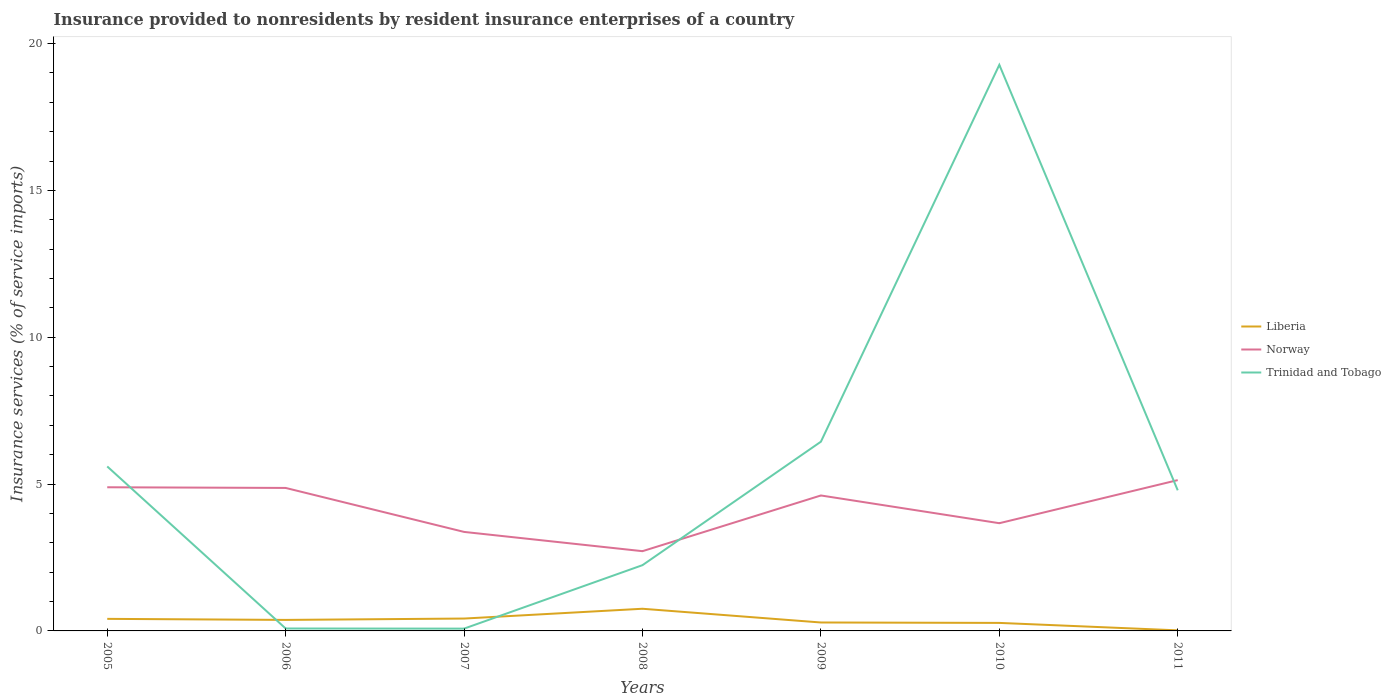How many different coloured lines are there?
Give a very brief answer. 3. Is the number of lines equal to the number of legend labels?
Give a very brief answer. Yes. Across all years, what is the maximum insurance provided to nonresidents in Trinidad and Tobago?
Provide a succinct answer. 0.08. In which year was the insurance provided to nonresidents in Liberia maximum?
Offer a very short reply. 2011. What is the total insurance provided to nonresidents in Trinidad and Tobago in the graph?
Offer a terse response. -19.2. What is the difference between the highest and the second highest insurance provided to nonresidents in Norway?
Offer a very short reply. 2.42. What is the difference between the highest and the lowest insurance provided to nonresidents in Trinidad and Tobago?
Your response must be concise. 3. Is the insurance provided to nonresidents in Norway strictly greater than the insurance provided to nonresidents in Liberia over the years?
Keep it short and to the point. No. Are the values on the major ticks of Y-axis written in scientific E-notation?
Make the answer very short. No. Does the graph contain any zero values?
Your answer should be compact. No. Where does the legend appear in the graph?
Ensure brevity in your answer.  Center right. What is the title of the graph?
Offer a terse response. Insurance provided to nonresidents by resident insurance enterprises of a country. What is the label or title of the Y-axis?
Provide a succinct answer. Insurance services (% of service imports). What is the Insurance services (% of service imports) in Liberia in 2005?
Offer a terse response. 0.41. What is the Insurance services (% of service imports) of Norway in 2005?
Ensure brevity in your answer.  4.89. What is the Insurance services (% of service imports) in Trinidad and Tobago in 2005?
Offer a terse response. 5.6. What is the Insurance services (% of service imports) of Liberia in 2006?
Provide a succinct answer. 0.38. What is the Insurance services (% of service imports) in Norway in 2006?
Ensure brevity in your answer.  4.87. What is the Insurance services (% of service imports) of Trinidad and Tobago in 2006?
Make the answer very short. 0.08. What is the Insurance services (% of service imports) of Liberia in 2007?
Provide a short and direct response. 0.42. What is the Insurance services (% of service imports) of Norway in 2007?
Offer a terse response. 3.37. What is the Insurance services (% of service imports) in Trinidad and Tobago in 2007?
Offer a very short reply. 0.08. What is the Insurance services (% of service imports) of Liberia in 2008?
Ensure brevity in your answer.  0.75. What is the Insurance services (% of service imports) of Norway in 2008?
Make the answer very short. 2.72. What is the Insurance services (% of service imports) of Trinidad and Tobago in 2008?
Your answer should be very brief. 2.24. What is the Insurance services (% of service imports) in Liberia in 2009?
Keep it short and to the point. 0.29. What is the Insurance services (% of service imports) of Norway in 2009?
Offer a very short reply. 4.61. What is the Insurance services (% of service imports) in Trinidad and Tobago in 2009?
Make the answer very short. 6.44. What is the Insurance services (% of service imports) in Liberia in 2010?
Keep it short and to the point. 0.27. What is the Insurance services (% of service imports) of Norway in 2010?
Your answer should be compact. 3.67. What is the Insurance services (% of service imports) of Trinidad and Tobago in 2010?
Give a very brief answer. 19.28. What is the Insurance services (% of service imports) of Liberia in 2011?
Offer a terse response. 0.02. What is the Insurance services (% of service imports) of Norway in 2011?
Offer a terse response. 5.14. What is the Insurance services (% of service imports) of Trinidad and Tobago in 2011?
Make the answer very short. 4.79. Across all years, what is the maximum Insurance services (% of service imports) in Liberia?
Offer a very short reply. 0.75. Across all years, what is the maximum Insurance services (% of service imports) of Norway?
Give a very brief answer. 5.14. Across all years, what is the maximum Insurance services (% of service imports) of Trinidad and Tobago?
Your answer should be very brief. 19.28. Across all years, what is the minimum Insurance services (% of service imports) of Liberia?
Ensure brevity in your answer.  0.02. Across all years, what is the minimum Insurance services (% of service imports) in Norway?
Your answer should be compact. 2.72. Across all years, what is the minimum Insurance services (% of service imports) in Trinidad and Tobago?
Make the answer very short. 0.08. What is the total Insurance services (% of service imports) in Liberia in the graph?
Offer a very short reply. 2.54. What is the total Insurance services (% of service imports) of Norway in the graph?
Your response must be concise. 29.26. What is the total Insurance services (% of service imports) of Trinidad and Tobago in the graph?
Provide a succinct answer. 38.51. What is the difference between the Insurance services (% of service imports) in Liberia in 2005 and that in 2006?
Give a very brief answer. 0.04. What is the difference between the Insurance services (% of service imports) in Norway in 2005 and that in 2006?
Provide a succinct answer. 0.02. What is the difference between the Insurance services (% of service imports) in Trinidad and Tobago in 2005 and that in 2006?
Provide a succinct answer. 5.52. What is the difference between the Insurance services (% of service imports) of Liberia in 2005 and that in 2007?
Offer a very short reply. -0.01. What is the difference between the Insurance services (% of service imports) of Norway in 2005 and that in 2007?
Ensure brevity in your answer.  1.52. What is the difference between the Insurance services (% of service imports) in Trinidad and Tobago in 2005 and that in 2007?
Your response must be concise. 5.52. What is the difference between the Insurance services (% of service imports) of Liberia in 2005 and that in 2008?
Your response must be concise. -0.34. What is the difference between the Insurance services (% of service imports) of Norway in 2005 and that in 2008?
Offer a very short reply. 2.18. What is the difference between the Insurance services (% of service imports) of Trinidad and Tobago in 2005 and that in 2008?
Ensure brevity in your answer.  3.36. What is the difference between the Insurance services (% of service imports) in Liberia in 2005 and that in 2009?
Offer a terse response. 0.12. What is the difference between the Insurance services (% of service imports) of Norway in 2005 and that in 2009?
Provide a short and direct response. 0.28. What is the difference between the Insurance services (% of service imports) of Trinidad and Tobago in 2005 and that in 2009?
Your answer should be very brief. -0.84. What is the difference between the Insurance services (% of service imports) of Liberia in 2005 and that in 2010?
Ensure brevity in your answer.  0.14. What is the difference between the Insurance services (% of service imports) in Norway in 2005 and that in 2010?
Offer a terse response. 1.22. What is the difference between the Insurance services (% of service imports) of Trinidad and Tobago in 2005 and that in 2010?
Provide a short and direct response. -13.67. What is the difference between the Insurance services (% of service imports) of Liberia in 2005 and that in 2011?
Your response must be concise. 0.39. What is the difference between the Insurance services (% of service imports) of Norway in 2005 and that in 2011?
Your response must be concise. -0.24. What is the difference between the Insurance services (% of service imports) in Trinidad and Tobago in 2005 and that in 2011?
Provide a succinct answer. 0.81. What is the difference between the Insurance services (% of service imports) in Liberia in 2006 and that in 2007?
Your answer should be very brief. -0.05. What is the difference between the Insurance services (% of service imports) of Norway in 2006 and that in 2007?
Your response must be concise. 1.5. What is the difference between the Insurance services (% of service imports) of Trinidad and Tobago in 2006 and that in 2007?
Provide a short and direct response. 0. What is the difference between the Insurance services (% of service imports) in Liberia in 2006 and that in 2008?
Offer a terse response. -0.38. What is the difference between the Insurance services (% of service imports) of Norway in 2006 and that in 2008?
Provide a short and direct response. 2.15. What is the difference between the Insurance services (% of service imports) in Trinidad and Tobago in 2006 and that in 2008?
Ensure brevity in your answer.  -2.16. What is the difference between the Insurance services (% of service imports) in Liberia in 2006 and that in 2009?
Keep it short and to the point. 0.09. What is the difference between the Insurance services (% of service imports) of Norway in 2006 and that in 2009?
Your answer should be compact. 0.26. What is the difference between the Insurance services (% of service imports) of Trinidad and Tobago in 2006 and that in 2009?
Provide a short and direct response. -6.36. What is the difference between the Insurance services (% of service imports) in Liberia in 2006 and that in 2010?
Ensure brevity in your answer.  0.1. What is the difference between the Insurance services (% of service imports) of Norway in 2006 and that in 2010?
Provide a succinct answer. 1.2. What is the difference between the Insurance services (% of service imports) in Trinidad and Tobago in 2006 and that in 2010?
Provide a succinct answer. -19.19. What is the difference between the Insurance services (% of service imports) in Liberia in 2006 and that in 2011?
Your response must be concise. 0.36. What is the difference between the Insurance services (% of service imports) in Norway in 2006 and that in 2011?
Ensure brevity in your answer.  -0.27. What is the difference between the Insurance services (% of service imports) in Trinidad and Tobago in 2006 and that in 2011?
Make the answer very short. -4.71. What is the difference between the Insurance services (% of service imports) of Liberia in 2007 and that in 2008?
Give a very brief answer. -0.33. What is the difference between the Insurance services (% of service imports) in Norway in 2007 and that in 2008?
Provide a short and direct response. 0.66. What is the difference between the Insurance services (% of service imports) in Trinidad and Tobago in 2007 and that in 2008?
Offer a very short reply. -2.16. What is the difference between the Insurance services (% of service imports) in Liberia in 2007 and that in 2009?
Offer a terse response. 0.13. What is the difference between the Insurance services (% of service imports) of Norway in 2007 and that in 2009?
Offer a very short reply. -1.24. What is the difference between the Insurance services (% of service imports) of Trinidad and Tobago in 2007 and that in 2009?
Provide a succinct answer. -6.37. What is the difference between the Insurance services (% of service imports) of Liberia in 2007 and that in 2010?
Your answer should be compact. 0.15. What is the difference between the Insurance services (% of service imports) in Norway in 2007 and that in 2010?
Offer a very short reply. -0.3. What is the difference between the Insurance services (% of service imports) in Trinidad and Tobago in 2007 and that in 2010?
Ensure brevity in your answer.  -19.2. What is the difference between the Insurance services (% of service imports) of Liberia in 2007 and that in 2011?
Your answer should be compact. 0.4. What is the difference between the Insurance services (% of service imports) of Norway in 2007 and that in 2011?
Give a very brief answer. -1.76. What is the difference between the Insurance services (% of service imports) in Trinidad and Tobago in 2007 and that in 2011?
Make the answer very short. -4.71. What is the difference between the Insurance services (% of service imports) of Liberia in 2008 and that in 2009?
Offer a very short reply. 0.47. What is the difference between the Insurance services (% of service imports) in Norway in 2008 and that in 2009?
Offer a very short reply. -1.9. What is the difference between the Insurance services (% of service imports) of Trinidad and Tobago in 2008 and that in 2009?
Offer a very short reply. -4.2. What is the difference between the Insurance services (% of service imports) in Liberia in 2008 and that in 2010?
Ensure brevity in your answer.  0.48. What is the difference between the Insurance services (% of service imports) of Norway in 2008 and that in 2010?
Your answer should be compact. -0.95. What is the difference between the Insurance services (% of service imports) in Trinidad and Tobago in 2008 and that in 2010?
Provide a succinct answer. -17.04. What is the difference between the Insurance services (% of service imports) of Liberia in 2008 and that in 2011?
Give a very brief answer. 0.74. What is the difference between the Insurance services (% of service imports) of Norway in 2008 and that in 2011?
Provide a succinct answer. -2.42. What is the difference between the Insurance services (% of service imports) in Trinidad and Tobago in 2008 and that in 2011?
Offer a very short reply. -2.55. What is the difference between the Insurance services (% of service imports) in Liberia in 2009 and that in 2010?
Offer a terse response. 0.01. What is the difference between the Insurance services (% of service imports) of Norway in 2009 and that in 2010?
Give a very brief answer. 0.94. What is the difference between the Insurance services (% of service imports) of Trinidad and Tobago in 2009 and that in 2010?
Your response must be concise. -12.83. What is the difference between the Insurance services (% of service imports) in Liberia in 2009 and that in 2011?
Keep it short and to the point. 0.27. What is the difference between the Insurance services (% of service imports) in Norway in 2009 and that in 2011?
Your response must be concise. -0.52. What is the difference between the Insurance services (% of service imports) in Trinidad and Tobago in 2009 and that in 2011?
Keep it short and to the point. 1.66. What is the difference between the Insurance services (% of service imports) of Liberia in 2010 and that in 2011?
Make the answer very short. 0.25. What is the difference between the Insurance services (% of service imports) of Norway in 2010 and that in 2011?
Make the answer very short. -1.47. What is the difference between the Insurance services (% of service imports) in Trinidad and Tobago in 2010 and that in 2011?
Offer a very short reply. 14.49. What is the difference between the Insurance services (% of service imports) in Liberia in 2005 and the Insurance services (% of service imports) in Norway in 2006?
Ensure brevity in your answer.  -4.46. What is the difference between the Insurance services (% of service imports) of Liberia in 2005 and the Insurance services (% of service imports) of Trinidad and Tobago in 2006?
Provide a succinct answer. 0.33. What is the difference between the Insurance services (% of service imports) of Norway in 2005 and the Insurance services (% of service imports) of Trinidad and Tobago in 2006?
Ensure brevity in your answer.  4.81. What is the difference between the Insurance services (% of service imports) in Liberia in 2005 and the Insurance services (% of service imports) in Norway in 2007?
Your answer should be compact. -2.96. What is the difference between the Insurance services (% of service imports) in Liberia in 2005 and the Insurance services (% of service imports) in Trinidad and Tobago in 2007?
Provide a succinct answer. 0.33. What is the difference between the Insurance services (% of service imports) of Norway in 2005 and the Insurance services (% of service imports) of Trinidad and Tobago in 2007?
Provide a succinct answer. 4.81. What is the difference between the Insurance services (% of service imports) in Liberia in 2005 and the Insurance services (% of service imports) in Norway in 2008?
Your response must be concise. -2.3. What is the difference between the Insurance services (% of service imports) of Liberia in 2005 and the Insurance services (% of service imports) of Trinidad and Tobago in 2008?
Offer a very short reply. -1.83. What is the difference between the Insurance services (% of service imports) in Norway in 2005 and the Insurance services (% of service imports) in Trinidad and Tobago in 2008?
Make the answer very short. 2.65. What is the difference between the Insurance services (% of service imports) in Liberia in 2005 and the Insurance services (% of service imports) in Norway in 2009?
Keep it short and to the point. -4.2. What is the difference between the Insurance services (% of service imports) in Liberia in 2005 and the Insurance services (% of service imports) in Trinidad and Tobago in 2009?
Your answer should be compact. -6.03. What is the difference between the Insurance services (% of service imports) in Norway in 2005 and the Insurance services (% of service imports) in Trinidad and Tobago in 2009?
Keep it short and to the point. -1.55. What is the difference between the Insurance services (% of service imports) of Liberia in 2005 and the Insurance services (% of service imports) of Norway in 2010?
Keep it short and to the point. -3.26. What is the difference between the Insurance services (% of service imports) in Liberia in 2005 and the Insurance services (% of service imports) in Trinidad and Tobago in 2010?
Your answer should be very brief. -18.86. What is the difference between the Insurance services (% of service imports) in Norway in 2005 and the Insurance services (% of service imports) in Trinidad and Tobago in 2010?
Give a very brief answer. -14.38. What is the difference between the Insurance services (% of service imports) of Liberia in 2005 and the Insurance services (% of service imports) of Norway in 2011?
Offer a terse response. -4.72. What is the difference between the Insurance services (% of service imports) in Liberia in 2005 and the Insurance services (% of service imports) in Trinidad and Tobago in 2011?
Your response must be concise. -4.38. What is the difference between the Insurance services (% of service imports) of Norway in 2005 and the Insurance services (% of service imports) of Trinidad and Tobago in 2011?
Your response must be concise. 0.1. What is the difference between the Insurance services (% of service imports) of Liberia in 2006 and the Insurance services (% of service imports) of Norway in 2007?
Provide a short and direct response. -3. What is the difference between the Insurance services (% of service imports) in Liberia in 2006 and the Insurance services (% of service imports) in Trinidad and Tobago in 2007?
Keep it short and to the point. 0.3. What is the difference between the Insurance services (% of service imports) of Norway in 2006 and the Insurance services (% of service imports) of Trinidad and Tobago in 2007?
Offer a very short reply. 4.79. What is the difference between the Insurance services (% of service imports) of Liberia in 2006 and the Insurance services (% of service imports) of Norway in 2008?
Provide a short and direct response. -2.34. What is the difference between the Insurance services (% of service imports) in Liberia in 2006 and the Insurance services (% of service imports) in Trinidad and Tobago in 2008?
Give a very brief answer. -1.86. What is the difference between the Insurance services (% of service imports) of Norway in 2006 and the Insurance services (% of service imports) of Trinidad and Tobago in 2008?
Provide a short and direct response. 2.63. What is the difference between the Insurance services (% of service imports) in Liberia in 2006 and the Insurance services (% of service imports) in Norway in 2009?
Make the answer very short. -4.24. What is the difference between the Insurance services (% of service imports) of Liberia in 2006 and the Insurance services (% of service imports) of Trinidad and Tobago in 2009?
Offer a terse response. -6.07. What is the difference between the Insurance services (% of service imports) of Norway in 2006 and the Insurance services (% of service imports) of Trinidad and Tobago in 2009?
Keep it short and to the point. -1.58. What is the difference between the Insurance services (% of service imports) in Liberia in 2006 and the Insurance services (% of service imports) in Norway in 2010?
Offer a very short reply. -3.29. What is the difference between the Insurance services (% of service imports) in Liberia in 2006 and the Insurance services (% of service imports) in Trinidad and Tobago in 2010?
Provide a succinct answer. -18.9. What is the difference between the Insurance services (% of service imports) in Norway in 2006 and the Insurance services (% of service imports) in Trinidad and Tobago in 2010?
Ensure brevity in your answer.  -14.41. What is the difference between the Insurance services (% of service imports) of Liberia in 2006 and the Insurance services (% of service imports) of Norway in 2011?
Keep it short and to the point. -4.76. What is the difference between the Insurance services (% of service imports) in Liberia in 2006 and the Insurance services (% of service imports) in Trinidad and Tobago in 2011?
Make the answer very short. -4.41. What is the difference between the Insurance services (% of service imports) in Norway in 2006 and the Insurance services (% of service imports) in Trinidad and Tobago in 2011?
Provide a short and direct response. 0.08. What is the difference between the Insurance services (% of service imports) in Liberia in 2007 and the Insurance services (% of service imports) in Norway in 2008?
Provide a succinct answer. -2.29. What is the difference between the Insurance services (% of service imports) of Liberia in 2007 and the Insurance services (% of service imports) of Trinidad and Tobago in 2008?
Ensure brevity in your answer.  -1.82. What is the difference between the Insurance services (% of service imports) in Norway in 2007 and the Insurance services (% of service imports) in Trinidad and Tobago in 2008?
Your answer should be very brief. 1.13. What is the difference between the Insurance services (% of service imports) of Liberia in 2007 and the Insurance services (% of service imports) of Norway in 2009?
Provide a short and direct response. -4.19. What is the difference between the Insurance services (% of service imports) in Liberia in 2007 and the Insurance services (% of service imports) in Trinidad and Tobago in 2009?
Offer a terse response. -6.02. What is the difference between the Insurance services (% of service imports) of Norway in 2007 and the Insurance services (% of service imports) of Trinidad and Tobago in 2009?
Your answer should be compact. -3.07. What is the difference between the Insurance services (% of service imports) in Liberia in 2007 and the Insurance services (% of service imports) in Norway in 2010?
Provide a succinct answer. -3.25. What is the difference between the Insurance services (% of service imports) of Liberia in 2007 and the Insurance services (% of service imports) of Trinidad and Tobago in 2010?
Provide a short and direct response. -18.85. What is the difference between the Insurance services (% of service imports) of Norway in 2007 and the Insurance services (% of service imports) of Trinidad and Tobago in 2010?
Give a very brief answer. -15.9. What is the difference between the Insurance services (% of service imports) of Liberia in 2007 and the Insurance services (% of service imports) of Norway in 2011?
Your response must be concise. -4.71. What is the difference between the Insurance services (% of service imports) in Liberia in 2007 and the Insurance services (% of service imports) in Trinidad and Tobago in 2011?
Offer a very short reply. -4.37. What is the difference between the Insurance services (% of service imports) of Norway in 2007 and the Insurance services (% of service imports) of Trinidad and Tobago in 2011?
Keep it short and to the point. -1.42. What is the difference between the Insurance services (% of service imports) of Liberia in 2008 and the Insurance services (% of service imports) of Norway in 2009?
Make the answer very short. -3.86. What is the difference between the Insurance services (% of service imports) in Liberia in 2008 and the Insurance services (% of service imports) in Trinidad and Tobago in 2009?
Your answer should be compact. -5.69. What is the difference between the Insurance services (% of service imports) of Norway in 2008 and the Insurance services (% of service imports) of Trinidad and Tobago in 2009?
Your answer should be very brief. -3.73. What is the difference between the Insurance services (% of service imports) in Liberia in 2008 and the Insurance services (% of service imports) in Norway in 2010?
Your response must be concise. -2.91. What is the difference between the Insurance services (% of service imports) in Liberia in 2008 and the Insurance services (% of service imports) in Trinidad and Tobago in 2010?
Your answer should be very brief. -18.52. What is the difference between the Insurance services (% of service imports) in Norway in 2008 and the Insurance services (% of service imports) in Trinidad and Tobago in 2010?
Give a very brief answer. -16.56. What is the difference between the Insurance services (% of service imports) of Liberia in 2008 and the Insurance services (% of service imports) of Norway in 2011?
Your answer should be very brief. -4.38. What is the difference between the Insurance services (% of service imports) in Liberia in 2008 and the Insurance services (% of service imports) in Trinidad and Tobago in 2011?
Provide a succinct answer. -4.03. What is the difference between the Insurance services (% of service imports) of Norway in 2008 and the Insurance services (% of service imports) of Trinidad and Tobago in 2011?
Provide a short and direct response. -2.07. What is the difference between the Insurance services (% of service imports) of Liberia in 2009 and the Insurance services (% of service imports) of Norway in 2010?
Keep it short and to the point. -3.38. What is the difference between the Insurance services (% of service imports) in Liberia in 2009 and the Insurance services (% of service imports) in Trinidad and Tobago in 2010?
Your response must be concise. -18.99. What is the difference between the Insurance services (% of service imports) in Norway in 2009 and the Insurance services (% of service imports) in Trinidad and Tobago in 2010?
Your answer should be very brief. -14.66. What is the difference between the Insurance services (% of service imports) of Liberia in 2009 and the Insurance services (% of service imports) of Norway in 2011?
Give a very brief answer. -4.85. What is the difference between the Insurance services (% of service imports) of Liberia in 2009 and the Insurance services (% of service imports) of Trinidad and Tobago in 2011?
Ensure brevity in your answer.  -4.5. What is the difference between the Insurance services (% of service imports) of Norway in 2009 and the Insurance services (% of service imports) of Trinidad and Tobago in 2011?
Your answer should be very brief. -0.18. What is the difference between the Insurance services (% of service imports) in Liberia in 2010 and the Insurance services (% of service imports) in Norway in 2011?
Your response must be concise. -4.86. What is the difference between the Insurance services (% of service imports) in Liberia in 2010 and the Insurance services (% of service imports) in Trinidad and Tobago in 2011?
Give a very brief answer. -4.52. What is the difference between the Insurance services (% of service imports) in Norway in 2010 and the Insurance services (% of service imports) in Trinidad and Tobago in 2011?
Your response must be concise. -1.12. What is the average Insurance services (% of service imports) in Liberia per year?
Make the answer very short. 0.36. What is the average Insurance services (% of service imports) of Norway per year?
Your answer should be compact. 4.18. What is the average Insurance services (% of service imports) in Trinidad and Tobago per year?
Provide a succinct answer. 5.5. In the year 2005, what is the difference between the Insurance services (% of service imports) in Liberia and Insurance services (% of service imports) in Norway?
Provide a succinct answer. -4.48. In the year 2005, what is the difference between the Insurance services (% of service imports) of Liberia and Insurance services (% of service imports) of Trinidad and Tobago?
Offer a very short reply. -5.19. In the year 2005, what is the difference between the Insurance services (% of service imports) in Norway and Insurance services (% of service imports) in Trinidad and Tobago?
Your answer should be compact. -0.71. In the year 2006, what is the difference between the Insurance services (% of service imports) in Liberia and Insurance services (% of service imports) in Norway?
Offer a very short reply. -4.49. In the year 2006, what is the difference between the Insurance services (% of service imports) of Liberia and Insurance services (% of service imports) of Trinidad and Tobago?
Provide a succinct answer. 0.29. In the year 2006, what is the difference between the Insurance services (% of service imports) in Norway and Insurance services (% of service imports) in Trinidad and Tobago?
Offer a very short reply. 4.79. In the year 2007, what is the difference between the Insurance services (% of service imports) of Liberia and Insurance services (% of service imports) of Norway?
Provide a succinct answer. -2.95. In the year 2007, what is the difference between the Insurance services (% of service imports) of Liberia and Insurance services (% of service imports) of Trinidad and Tobago?
Keep it short and to the point. 0.34. In the year 2007, what is the difference between the Insurance services (% of service imports) of Norway and Insurance services (% of service imports) of Trinidad and Tobago?
Your answer should be compact. 3.29. In the year 2008, what is the difference between the Insurance services (% of service imports) in Liberia and Insurance services (% of service imports) in Norway?
Make the answer very short. -1.96. In the year 2008, what is the difference between the Insurance services (% of service imports) in Liberia and Insurance services (% of service imports) in Trinidad and Tobago?
Your answer should be compact. -1.48. In the year 2008, what is the difference between the Insurance services (% of service imports) in Norway and Insurance services (% of service imports) in Trinidad and Tobago?
Your response must be concise. 0.48. In the year 2009, what is the difference between the Insurance services (% of service imports) in Liberia and Insurance services (% of service imports) in Norway?
Provide a succinct answer. -4.33. In the year 2009, what is the difference between the Insurance services (% of service imports) of Liberia and Insurance services (% of service imports) of Trinidad and Tobago?
Keep it short and to the point. -6.16. In the year 2009, what is the difference between the Insurance services (% of service imports) of Norway and Insurance services (% of service imports) of Trinidad and Tobago?
Ensure brevity in your answer.  -1.83. In the year 2010, what is the difference between the Insurance services (% of service imports) of Liberia and Insurance services (% of service imports) of Norway?
Your response must be concise. -3.4. In the year 2010, what is the difference between the Insurance services (% of service imports) in Liberia and Insurance services (% of service imports) in Trinidad and Tobago?
Keep it short and to the point. -19. In the year 2010, what is the difference between the Insurance services (% of service imports) of Norway and Insurance services (% of service imports) of Trinidad and Tobago?
Give a very brief answer. -15.61. In the year 2011, what is the difference between the Insurance services (% of service imports) in Liberia and Insurance services (% of service imports) in Norway?
Your answer should be compact. -5.12. In the year 2011, what is the difference between the Insurance services (% of service imports) in Liberia and Insurance services (% of service imports) in Trinidad and Tobago?
Your answer should be compact. -4.77. In the year 2011, what is the difference between the Insurance services (% of service imports) in Norway and Insurance services (% of service imports) in Trinidad and Tobago?
Offer a very short reply. 0.35. What is the ratio of the Insurance services (% of service imports) in Liberia in 2005 to that in 2006?
Keep it short and to the point. 1.1. What is the ratio of the Insurance services (% of service imports) in Trinidad and Tobago in 2005 to that in 2006?
Offer a very short reply. 67.73. What is the ratio of the Insurance services (% of service imports) in Liberia in 2005 to that in 2007?
Your response must be concise. 0.98. What is the ratio of the Insurance services (% of service imports) of Norway in 2005 to that in 2007?
Your answer should be compact. 1.45. What is the ratio of the Insurance services (% of service imports) in Trinidad and Tobago in 2005 to that in 2007?
Ensure brevity in your answer.  71.7. What is the ratio of the Insurance services (% of service imports) in Liberia in 2005 to that in 2008?
Your response must be concise. 0.54. What is the ratio of the Insurance services (% of service imports) in Norway in 2005 to that in 2008?
Your answer should be compact. 1.8. What is the ratio of the Insurance services (% of service imports) in Trinidad and Tobago in 2005 to that in 2008?
Your answer should be very brief. 2.5. What is the ratio of the Insurance services (% of service imports) in Liberia in 2005 to that in 2009?
Your response must be concise. 1.43. What is the ratio of the Insurance services (% of service imports) in Norway in 2005 to that in 2009?
Give a very brief answer. 1.06. What is the ratio of the Insurance services (% of service imports) of Trinidad and Tobago in 2005 to that in 2009?
Your response must be concise. 0.87. What is the ratio of the Insurance services (% of service imports) in Liberia in 2005 to that in 2010?
Provide a succinct answer. 1.5. What is the ratio of the Insurance services (% of service imports) in Norway in 2005 to that in 2010?
Keep it short and to the point. 1.33. What is the ratio of the Insurance services (% of service imports) of Trinidad and Tobago in 2005 to that in 2010?
Offer a terse response. 0.29. What is the ratio of the Insurance services (% of service imports) in Liberia in 2005 to that in 2011?
Keep it short and to the point. 21.17. What is the ratio of the Insurance services (% of service imports) in Norway in 2005 to that in 2011?
Provide a short and direct response. 0.95. What is the ratio of the Insurance services (% of service imports) in Trinidad and Tobago in 2005 to that in 2011?
Your response must be concise. 1.17. What is the ratio of the Insurance services (% of service imports) of Liberia in 2006 to that in 2007?
Your response must be concise. 0.89. What is the ratio of the Insurance services (% of service imports) of Norway in 2006 to that in 2007?
Offer a terse response. 1.44. What is the ratio of the Insurance services (% of service imports) of Trinidad and Tobago in 2006 to that in 2007?
Offer a very short reply. 1.06. What is the ratio of the Insurance services (% of service imports) of Liberia in 2006 to that in 2008?
Give a very brief answer. 0.5. What is the ratio of the Insurance services (% of service imports) of Norway in 2006 to that in 2008?
Offer a terse response. 1.79. What is the ratio of the Insurance services (% of service imports) of Trinidad and Tobago in 2006 to that in 2008?
Your response must be concise. 0.04. What is the ratio of the Insurance services (% of service imports) in Liberia in 2006 to that in 2009?
Make the answer very short. 1.31. What is the ratio of the Insurance services (% of service imports) of Norway in 2006 to that in 2009?
Provide a succinct answer. 1.06. What is the ratio of the Insurance services (% of service imports) of Trinidad and Tobago in 2006 to that in 2009?
Keep it short and to the point. 0.01. What is the ratio of the Insurance services (% of service imports) of Liberia in 2006 to that in 2010?
Offer a terse response. 1.37. What is the ratio of the Insurance services (% of service imports) of Norway in 2006 to that in 2010?
Your response must be concise. 1.33. What is the ratio of the Insurance services (% of service imports) in Trinidad and Tobago in 2006 to that in 2010?
Ensure brevity in your answer.  0. What is the ratio of the Insurance services (% of service imports) in Liberia in 2006 to that in 2011?
Offer a terse response. 19.33. What is the ratio of the Insurance services (% of service imports) of Norway in 2006 to that in 2011?
Keep it short and to the point. 0.95. What is the ratio of the Insurance services (% of service imports) of Trinidad and Tobago in 2006 to that in 2011?
Your answer should be compact. 0.02. What is the ratio of the Insurance services (% of service imports) of Liberia in 2007 to that in 2008?
Give a very brief answer. 0.56. What is the ratio of the Insurance services (% of service imports) of Norway in 2007 to that in 2008?
Provide a succinct answer. 1.24. What is the ratio of the Insurance services (% of service imports) in Trinidad and Tobago in 2007 to that in 2008?
Your answer should be very brief. 0.03. What is the ratio of the Insurance services (% of service imports) in Liberia in 2007 to that in 2009?
Keep it short and to the point. 1.47. What is the ratio of the Insurance services (% of service imports) of Norway in 2007 to that in 2009?
Make the answer very short. 0.73. What is the ratio of the Insurance services (% of service imports) of Trinidad and Tobago in 2007 to that in 2009?
Ensure brevity in your answer.  0.01. What is the ratio of the Insurance services (% of service imports) of Liberia in 2007 to that in 2010?
Make the answer very short. 1.54. What is the ratio of the Insurance services (% of service imports) in Norway in 2007 to that in 2010?
Make the answer very short. 0.92. What is the ratio of the Insurance services (% of service imports) of Trinidad and Tobago in 2007 to that in 2010?
Keep it short and to the point. 0. What is the ratio of the Insurance services (% of service imports) of Liberia in 2007 to that in 2011?
Your answer should be very brief. 21.71. What is the ratio of the Insurance services (% of service imports) of Norway in 2007 to that in 2011?
Ensure brevity in your answer.  0.66. What is the ratio of the Insurance services (% of service imports) in Trinidad and Tobago in 2007 to that in 2011?
Provide a short and direct response. 0.02. What is the ratio of the Insurance services (% of service imports) of Liberia in 2008 to that in 2009?
Provide a succinct answer. 2.63. What is the ratio of the Insurance services (% of service imports) of Norway in 2008 to that in 2009?
Your answer should be compact. 0.59. What is the ratio of the Insurance services (% of service imports) of Trinidad and Tobago in 2008 to that in 2009?
Give a very brief answer. 0.35. What is the ratio of the Insurance services (% of service imports) of Liberia in 2008 to that in 2010?
Your response must be concise. 2.77. What is the ratio of the Insurance services (% of service imports) in Norway in 2008 to that in 2010?
Your answer should be compact. 0.74. What is the ratio of the Insurance services (% of service imports) in Trinidad and Tobago in 2008 to that in 2010?
Give a very brief answer. 0.12. What is the ratio of the Insurance services (% of service imports) in Liberia in 2008 to that in 2011?
Give a very brief answer. 38.9. What is the ratio of the Insurance services (% of service imports) of Norway in 2008 to that in 2011?
Your response must be concise. 0.53. What is the ratio of the Insurance services (% of service imports) of Trinidad and Tobago in 2008 to that in 2011?
Ensure brevity in your answer.  0.47. What is the ratio of the Insurance services (% of service imports) in Liberia in 2009 to that in 2010?
Provide a short and direct response. 1.05. What is the ratio of the Insurance services (% of service imports) of Norway in 2009 to that in 2010?
Keep it short and to the point. 1.26. What is the ratio of the Insurance services (% of service imports) in Trinidad and Tobago in 2009 to that in 2010?
Keep it short and to the point. 0.33. What is the ratio of the Insurance services (% of service imports) in Liberia in 2009 to that in 2011?
Your response must be concise. 14.8. What is the ratio of the Insurance services (% of service imports) in Norway in 2009 to that in 2011?
Your answer should be very brief. 0.9. What is the ratio of the Insurance services (% of service imports) of Trinidad and Tobago in 2009 to that in 2011?
Your answer should be very brief. 1.35. What is the ratio of the Insurance services (% of service imports) in Liberia in 2010 to that in 2011?
Provide a succinct answer. 14.07. What is the ratio of the Insurance services (% of service imports) in Norway in 2010 to that in 2011?
Offer a terse response. 0.71. What is the ratio of the Insurance services (% of service imports) in Trinidad and Tobago in 2010 to that in 2011?
Your answer should be compact. 4.03. What is the difference between the highest and the second highest Insurance services (% of service imports) in Liberia?
Give a very brief answer. 0.33. What is the difference between the highest and the second highest Insurance services (% of service imports) in Norway?
Provide a short and direct response. 0.24. What is the difference between the highest and the second highest Insurance services (% of service imports) in Trinidad and Tobago?
Provide a short and direct response. 12.83. What is the difference between the highest and the lowest Insurance services (% of service imports) in Liberia?
Make the answer very short. 0.74. What is the difference between the highest and the lowest Insurance services (% of service imports) in Norway?
Offer a very short reply. 2.42. What is the difference between the highest and the lowest Insurance services (% of service imports) of Trinidad and Tobago?
Keep it short and to the point. 19.2. 